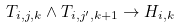Convert formula to latex. <formula><loc_0><loc_0><loc_500><loc_500>T _ { i , j , k } \land T _ { i , j ^ { \prime } , k + 1 } \rightarrow H _ { i , k }</formula> 